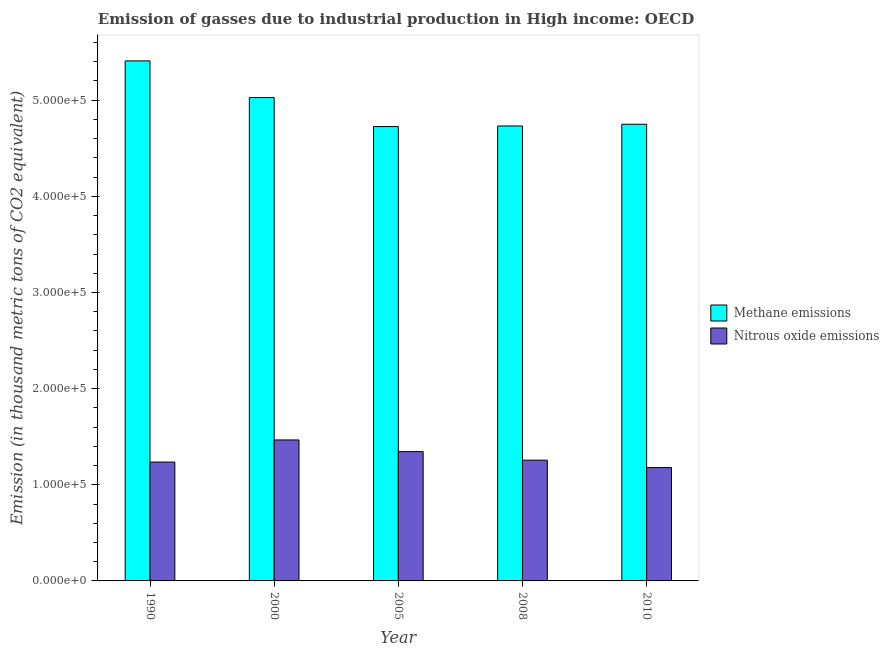Are the number of bars per tick equal to the number of legend labels?
Your response must be concise. Yes. What is the label of the 1st group of bars from the left?
Ensure brevity in your answer.  1990. In how many cases, is the number of bars for a given year not equal to the number of legend labels?
Make the answer very short. 0. What is the amount of methane emissions in 1990?
Provide a short and direct response. 5.41e+05. Across all years, what is the maximum amount of nitrous oxide emissions?
Make the answer very short. 1.47e+05. Across all years, what is the minimum amount of methane emissions?
Your answer should be compact. 4.73e+05. In which year was the amount of methane emissions maximum?
Provide a short and direct response. 1990. What is the total amount of nitrous oxide emissions in the graph?
Offer a terse response. 6.48e+05. What is the difference between the amount of nitrous oxide emissions in 1990 and that in 2008?
Your answer should be very brief. -1956.6. What is the difference between the amount of nitrous oxide emissions in 2005 and the amount of methane emissions in 2008?
Offer a terse response. 8873.1. What is the average amount of methane emissions per year?
Offer a terse response. 4.93e+05. In the year 1990, what is the difference between the amount of methane emissions and amount of nitrous oxide emissions?
Your answer should be compact. 0. In how many years, is the amount of methane emissions greater than 520000 thousand metric tons?
Keep it short and to the point. 1. What is the ratio of the amount of methane emissions in 2008 to that in 2010?
Your answer should be compact. 1. Is the amount of methane emissions in 2005 less than that in 2010?
Provide a short and direct response. Yes. What is the difference between the highest and the second highest amount of nitrous oxide emissions?
Keep it short and to the point. 1.22e+04. What is the difference between the highest and the lowest amount of nitrous oxide emissions?
Ensure brevity in your answer.  2.87e+04. What does the 2nd bar from the left in 2005 represents?
Your answer should be very brief. Nitrous oxide emissions. What does the 2nd bar from the right in 2005 represents?
Give a very brief answer. Methane emissions. Are all the bars in the graph horizontal?
Your answer should be very brief. No. What is the difference between two consecutive major ticks on the Y-axis?
Keep it short and to the point. 1.00e+05. Are the values on the major ticks of Y-axis written in scientific E-notation?
Ensure brevity in your answer.  Yes. Does the graph contain any zero values?
Provide a short and direct response. No. Does the graph contain grids?
Make the answer very short. No. How many legend labels are there?
Keep it short and to the point. 2. How are the legend labels stacked?
Keep it short and to the point. Vertical. What is the title of the graph?
Give a very brief answer. Emission of gasses due to industrial production in High income: OECD. Does "Domestic Liabilities" appear as one of the legend labels in the graph?
Provide a short and direct response. No. What is the label or title of the Y-axis?
Offer a very short reply. Emission (in thousand metric tons of CO2 equivalent). What is the Emission (in thousand metric tons of CO2 equivalent) in Methane emissions in 1990?
Keep it short and to the point. 5.41e+05. What is the Emission (in thousand metric tons of CO2 equivalent) in Nitrous oxide emissions in 1990?
Make the answer very short. 1.24e+05. What is the Emission (in thousand metric tons of CO2 equivalent) of Methane emissions in 2000?
Give a very brief answer. 5.03e+05. What is the Emission (in thousand metric tons of CO2 equivalent) of Nitrous oxide emissions in 2000?
Your answer should be very brief. 1.47e+05. What is the Emission (in thousand metric tons of CO2 equivalent) of Methane emissions in 2005?
Make the answer very short. 4.73e+05. What is the Emission (in thousand metric tons of CO2 equivalent) in Nitrous oxide emissions in 2005?
Your answer should be very brief. 1.34e+05. What is the Emission (in thousand metric tons of CO2 equivalent) of Methane emissions in 2008?
Make the answer very short. 4.73e+05. What is the Emission (in thousand metric tons of CO2 equivalent) of Nitrous oxide emissions in 2008?
Your answer should be compact. 1.26e+05. What is the Emission (in thousand metric tons of CO2 equivalent) of Methane emissions in 2010?
Your answer should be compact. 4.75e+05. What is the Emission (in thousand metric tons of CO2 equivalent) in Nitrous oxide emissions in 2010?
Give a very brief answer. 1.18e+05. Across all years, what is the maximum Emission (in thousand metric tons of CO2 equivalent) in Methane emissions?
Your response must be concise. 5.41e+05. Across all years, what is the maximum Emission (in thousand metric tons of CO2 equivalent) in Nitrous oxide emissions?
Make the answer very short. 1.47e+05. Across all years, what is the minimum Emission (in thousand metric tons of CO2 equivalent) of Methane emissions?
Offer a terse response. 4.73e+05. Across all years, what is the minimum Emission (in thousand metric tons of CO2 equivalent) of Nitrous oxide emissions?
Make the answer very short. 1.18e+05. What is the total Emission (in thousand metric tons of CO2 equivalent) in Methane emissions in the graph?
Your answer should be compact. 2.46e+06. What is the total Emission (in thousand metric tons of CO2 equivalent) in Nitrous oxide emissions in the graph?
Your response must be concise. 6.48e+05. What is the difference between the Emission (in thousand metric tons of CO2 equivalent) in Methane emissions in 1990 and that in 2000?
Provide a short and direct response. 3.82e+04. What is the difference between the Emission (in thousand metric tons of CO2 equivalent) in Nitrous oxide emissions in 1990 and that in 2000?
Keep it short and to the point. -2.30e+04. What is the difference between the Emission (in thousand metric tons of CO2 equivalent) in Methane emissions in 1990 and that in 2005?
Your response must be concise. 6.83e+04. What is the difference between the Emission (in thousand metric tons of CO2 equivalent) of Nitrous oxide emissions in 1990 and that in 2005?
Provide a succinct answer. -1.08e+04. What is the difference between the Emission (in thousand metric tons of CO2 equivalent) in Methane emissions in 1990 and that in 2008?
Make the answer very short. 6.77e+04. What is the difference between the Emission (in thousand metric tons of CO2 equivalent) in Nitrous oxide emissions in 1990 and that in 2008?
Provide a short and direct response. -1956.6. What is the difference between the Emission (in thousand metric tons of CO2 equivalent) of Methane emissions in 1990 and that in 2010?
Provide a short and direct response. 6.59e+04. What is the difference between the Emission (in thousand metric tons of CO2 equivalent) of Nitrous oxide emissions in 1990 and that in 2010?
Provide a short and direct response. 5738. What is the difference between the Emission (in thousand metric tons of CO2 equivalent) in Methane emissions in 2000 and that in 2005?
Give a very brief answer. 3.02e+04. What is the difference between the Emission (in thousand metric tons of CO2 equivalent) in Nitrous oxide emissions in 2000 and that in 2005?
Keep it short and to the point. 1.22e+04. What is the difference between the Emission (in thousand metric tons of CO2 equivalent) of Methane emissions in 2000 and that in 2008?
Your answer should be very brief. 2.96e+04. What is the difference between the Emission (in thousand metric tons of CO2 equivalent) in Nitrous oxide emissions in 2000 and that in 2008?
Provide a short and direct response. 2.10e+04. What is the difference between the Emission (in thousand metric tons of CO2 equivalent) of Methane emissions in 2000 and that in 2010?
Offer a terse response. 2.78e+04. What is the difference between the Emission (in thousand metric tons of CO2 equivalent) of Nitrous oxide emissions in 2000 and that in 2010?
Give a very brief answer. 2.87e+04. What is the difference between the Emission (in thousand metric tons of CO2 equivalent) of Methane emissions in 2005 and that in 2008?
Keep it short and to the point. -593. What is the difference between the Emission (in thousand metric tons of CO2 equivalent) in Nitrous oxide emissions in 2005 and that in 2008?
Offer a very short reply. 8873.1. What is the difference between the Emission (in thousand metric tons of CO2 equivalent) of Methane emissions in 2005 and that in 2010?
Ensure brevity in your answer.  -2407.6. What is the difference between the Emission (in thousand metric tons of CO2 equivalent) in Nitrous oxide emissions in 2005 and that in 2010?
Offer a very short reply. 1.66e+04. What is the difference between the Emission (in thousand metric tons of CO2 equivalent) in Methane emissions in 2008 and that in 2010?
Offer a very short reply. -1814.6. What is the difference between the Emission (in thousand metric tons of CO2 equivalent) in Nitrous oxide emissions in 2008 and that in 2010?
Your answer should be compact. 7694.6. What is the difference between the Emission (in thousand metric tons of CO2 equivalent) of Methane emissions in 1990 and the Emission (in thousand metric tons of CO2 equivalent) of Nitrous oxide emissions in 2000?
Provide a short and direct response. 3.94e+05. What is the difference between the Emission (in thousand metric tons of CO2 equivalent) of Methane emissions in 1990 and the Emission (in thousand metric tons of CO2 equivalent) of Nitrous oxide emissions in 2005?
Offer a terse response. 4.06e+05. What is the difference between the Emission (in thousand metric tons of CO2 equivalent) of Methane emissions in 1990 and the Emission (in thousand metric tons of CO2 equivalent) of Nitrous oxide emissions in 2008?
Give a very brief answer. 4.15e+05. What is the difference between the Emission (in thousand metric tons of CO2 equivalent) of Methane emissions in 1990 and the Emission (in thousand metric tons of CO2 equivalent) of Nitrous oxide emissions in 2010?
Keep it short and to the point. 4.23e+05. What is the difference between the Emission (in thousand metric tons of CO2 equivalent) of Methane emissions in 2000 and the Emission (in thousand metric tons of CO2 equivalent) of Nitrous oxide emissions in 2005?
Offer a terse response. 3.68e+05. What is the difference between the Emission (in thousand metric tons of CO2 equivalent) in Methane emissions in 2000 and the Emission (in thousand metric tons of CO2 equivalent) in Nitrous oxide emissions in 2008?
Ensure brevity in your answer.  3.77e+05. What is the difference between the Emission (in thousand metric tons of CO2 equivalent) in Methane emissions in 2000 and the Emission (in thousand metric tons of CO2 equivalent) in Nitrous oxide emissions in 2010?
Offer a very short reply. 3.85e+05. What is the difference between the Emission (in thousand metric tons of CO2 equivalent) of Methane emissions in 2005 and the Emission (in thousand metric tons of CO2 equivalent) of Nitrous oxide emissions in 2008?
Offer a very short reply. 3.47e+05. What is the difference between the Emission (in thousand metric tons of CO2 equivalent) in Methane emissions in 2005 and the Emission (in thousand metric tons of CO2 equivalent) in Nitrous oxide emissions in 2010?
Keep it short and to the point. 3.55e+05. What is the difference between the Emission (in thousand metric tons of CO2 equivalent) in Methane emissions in 2008 and the Emission (in thousand metric tons of CO2 equivalent) in Nitrous oxide emissions in 2010?
Give a very brief answer. 3.55e+05. What is the average Emission (in thousand metric tons of CO2 equivalent) in Methane emissions per year?
Provide a succinct answer. 4.93e+05. What is the average Emission (in thousand metric tons of CO2 equivalent) of Nitrous oxide emissions per year?
Keep it short and to the point. 1.30e+05. In the year 1990, what is the difference between the Emission (in thousand metric tons of CO2 equivalent) in Methane emissions and Emission (in thousand metric tons of CO2 equivalent) in Nitrous oxide emissions?
Your answer should be very brief. 4.17e+05. In the year 2000, what is the difference between the Emission (in thousand metric tons of CO2 equivalent) in Methane emissions and Emission (in thousand metric tons of CO2 equivalent) in Nitrous oxide emissions?
Give a very brief answer. 3.56e+05. In the year 2005, what is the difference between the Emission (in thousand metric tons of CO2 equivalent) in Methane emissions and Emission (in thousand metric tons of CO2 equivalent) in Nitrous oxide emissions?
Provide a short and direct response. 3.38e+05. In the year 2008, what is the difference between the Emission (in thousand metric tons of CO2 equivalent) of Methane emissions and Emission (in thousand metric tons of CO2 equivalent) of Nitrous oxide emissions?
Provide a succinct answer. 3.48e+05. In the year 2010, what is the difference between the Emission (in thousand metric tons of CO2 equivalent) in Methane emissions and Emission (in thousand metric tons of CO2 equivalent) in Nitrous oxide emissions?
Provide a short and direct response. 3.57e+05. What is the ratio of the Emission (in thousand metric tons of CO2 equivalent) of Methane emissions in 1990 to that in 2000?
Provide a short and direct response. 1.08. What is the ratio of the Emission (in thousand metric tons of CO2 equivalent) of Nitrous oxide emissions in 1990 to that in 2000?
Your answer should be compact. 0.84. What is the ratio of the Emission (in thousand metric tons of CO2 equivalent) of Methane emissions in 1990 to that in 2005?
Give a very brief answer. 1.14. What is the ratio of the Emission (in thousand metric tons of CO2 equivalent) in Nitrous oxide emissions in 1990 to that in 2005?
Offer a terse response. 0.92. What is the ratio of the Emission (in thousand metric tons of CO2 equivalent) in Methane emissions in 1990 to that in 2008?
Your answer should be compact. 1.14. What is the ratio of the Emission (in thousand metric tons of CO2 equivalent) in Nitrous oxide emissions in 1990 to that in 2008?
Provide a succinct answer. 0.98. What is the ratio of the Emission (in thousand metric tons of CO2 equivalent) of Methane emissions in 1990 to that in 2010?
Your response must be concise. 1.14. What is the ratio of the Emission (in thousand metric tons of CO2 equivalent) in Nitrous oxide emissions in 1990 to that in 2010?
Offer a terse response. 1.05. What is the ratio of the Emission (in thousand metric tons of CO2 equivalent) in Methane emissions in 2000 to that in 2005?
Make the answer very short. 1.06. What is the ratio of the Emission (in thousand metric tons of CO2 equivalent) in Nitrous oxide emissions in 2000 to that in 2005?
Make the answer very short. 1.09. What is the ratio of the Emission (in thousand metric tons of CO2 equivalent) in Methane emissions in 2000 to that in 2008?
Give a very brief answer. 1.06. What is the ratio of the Emission (in thousand metric tons of CO2 equivalent) in Nitrous oxide emissions in 2000 to that in 2008?
Give a very brief answer. 1.17. What is the ratio of the Emission (in thousand metric tons of CO2 equivalent) in Methane emissions in 2000 to that in 2010?
Your answer should be very brief. 1.06. What is the ratio of the Emission (in thousand metric tons of CO2 equivalent) of Nitrous oxide emissions in 2000 to that in 2010?
Your answer should be compact. 1.24. What is the ratio of the Emission (in thousand metric tons of CO2 equivalent) in Methane emissions in 2005 to that in 2008?
Your response must be concise. 1. What is the ratio of the Emission (in thousand metric tons of CO2 equivalent) in Nitrous oxide emissions in 2005 to that in 2008?
Make the answer very short. 1.07. What is the ratio of the Emission (in thousand metric tons of CO2 equivalent) of Nitrous oxide emissions in 2005 to that in 2010?
Keep it short and to the point. 1.14. What is the ratio of the Emission (in thousand metric tons of CO2 equivalent) in Methane emissions in 2008 to that in 2010?
Offer a very short reply. 1. What is the ratio of the Emission (in thousand metric tons of CO2 equivalent) in Nitrous oxide emissions in 2008 to that in 2010?
Provide a short and direct response. 1.07. What is the difference between the highest and the second highest Emission (in thousand metric tons of CO2 equivalent) in Methane emissions?
Provide a succinct answer. 3.82e+04. What is the difference between the highest and the second highest Emission (in thousand metric tons of CO2 equivalent) of Nitrous oxide emissions?
Your answer should be very brief. 1.22e+04. What is the difference between the highest and the lowest Emission (in thousand metric tons of CO2 equivalent) in Methane emissions?
Provide a short and direct response. 6.83e+04. What is the difference between the highest and the lowest Emission (in thousand metric tons of CO2 equivalent) in Nitrous oxide emissions?
Ensure brevity in your answer.  2.87e+04. 